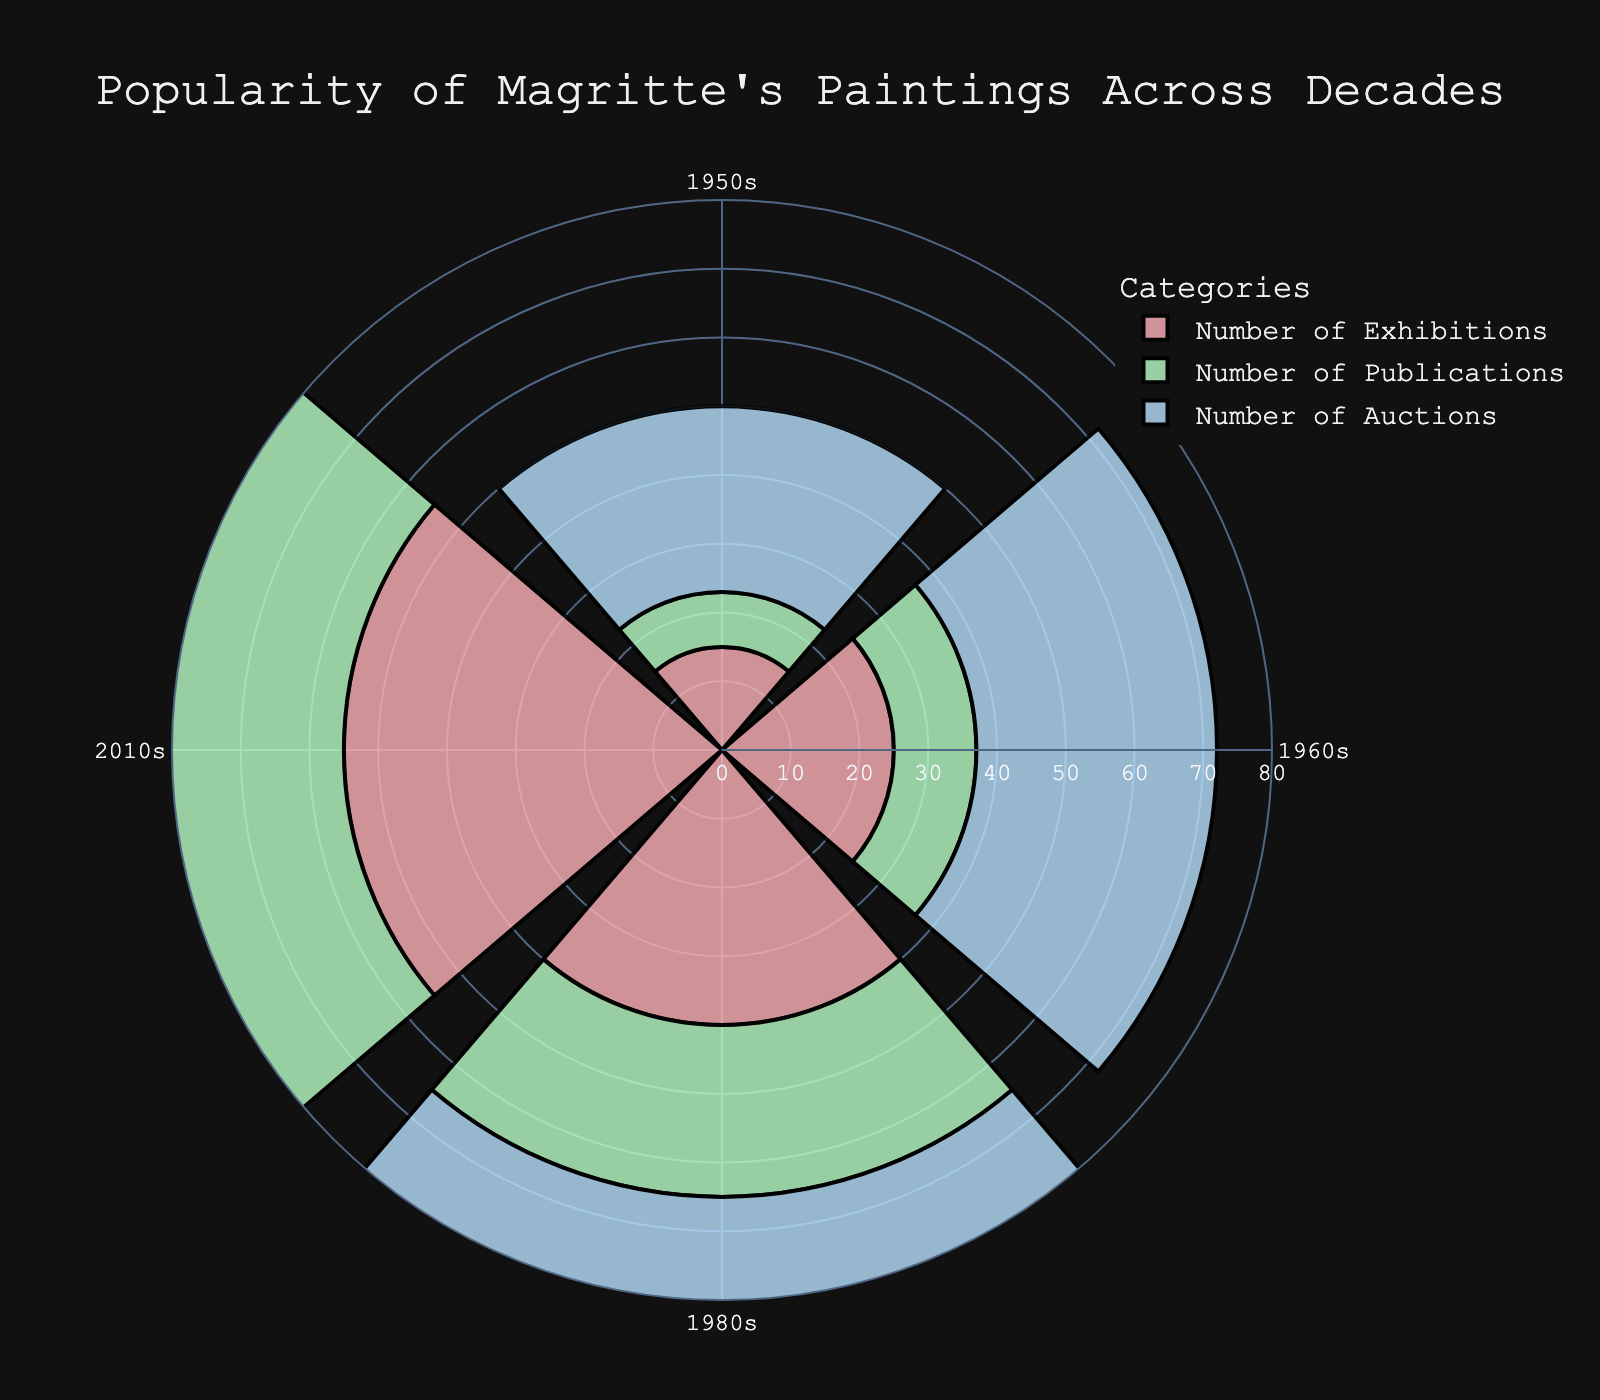What's the title of the chart? The title is usually displayed at the top of the chart. In this case, it reads "Popularity of Magritte's Paintings Across Decades."
Answer: Popularity of Magritte's Paintings Across Decades Which category has the highest value in the 2010s? We look at the 2010s and compare the lengths of the bars representing the three categories: Exhibitions, Publications, and Auctions. The longest bar represents Auctions with 78.
Answer: Auctions In which decade did the Number of Publications see the most significant increase compared to the previous decade? We compare the values of Publications between each consecutive decade: from 8 in the 1950s to 12 in the 1960s (+4), 12 to 25 in the 1980s (+13), and 25 to 45 in the 2010s (+20). The largest increase is from the 1980s to the 2010s by 20.
Answer: 2010s How many more Exhibitions were there in the 2010s compared to the 1950s? We subtract the number of Exhibitions in the 1950s (15) from the number in the 2010s (55), resulting in 55 - 15 = 40.
Answer: 40 Which decade had the least Number of Exhibitions? By visually comparing the heights of the Exhibitions bars, we see that the 1950s has the shortest bar with 15.
Answer: 1950s What is the total number of Auctions across all decades shown? We add the number of Auctions from all decades: 27 (1950s) + 35 (1960s) + 60 (1980s) + 78 (2010s) = 200.
Answer: 200 During which decade do we see the greatest improvement in the Number of Exhibitions compared to all categories? Calculate the differences for Exhibitions in each decade and compare with others: 15 (1950s), +10 (1960s), +15 (1980s), +15 (2010s). While all categories show improvement, the greatest relative increase is seen in Auctions (from 27 to 78) in 2010s.
Answer: 2010s Which category and decade combination shows the least relative growth compared to the previous decade? By comparing the relative growth for all categories and decades, the least relative growth is seen from 12 (1960s) to 25 (1980s) in Publications (an addition of 13) among categories.
Answer: Publications, 1980s 